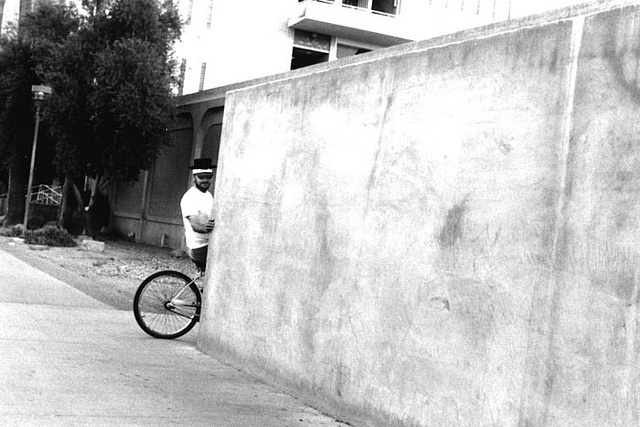Describe the objects in this image and their specific colors. I can see bicycle in darkgray, black, lightgray, and gray tones and people in darkgray, whitesmoke, black, and gray tones in this image. 